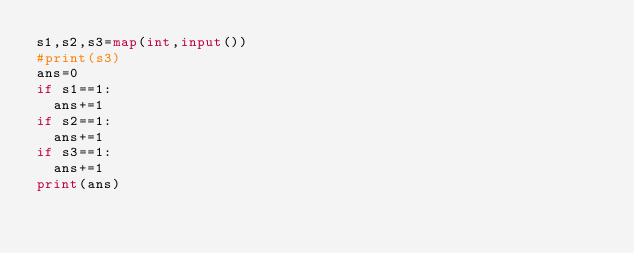Convert code to text. <code><loc_0><loc_0><loc_500><loc_500><_Python_>s1,s2,s3=map(int,input())
#print(s3)
ans=0
if s1==1:
  ans+=1
if s2==1:
  ans+=1
if s3==1:
  ans+=1
print(ans)</code> 